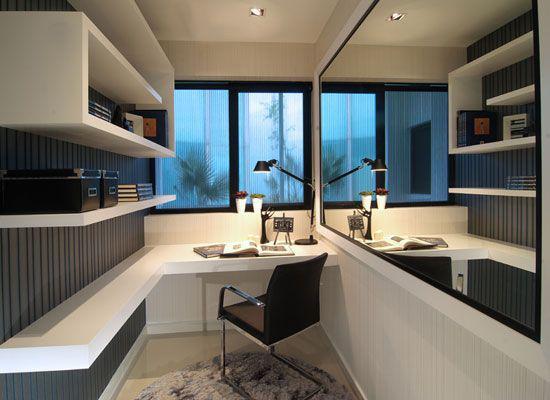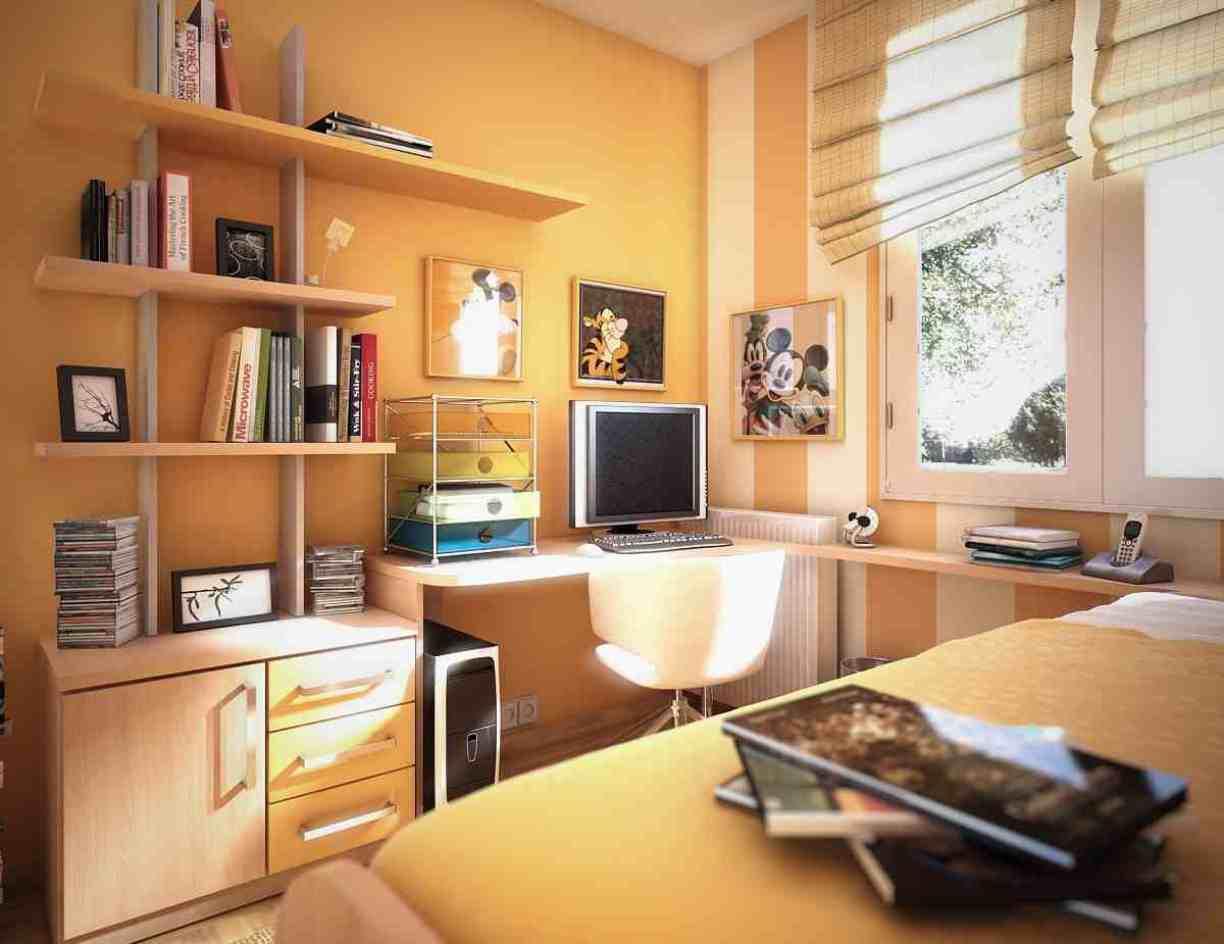The first image is the image on the left, the second image is the image on the right. Assess this claim about the two images: "The left image shows at least one chair in front of a pair of windows with a blue glow, and shelving along one wall.". Correct or not? Answer yes or no. Yes. The first image is the image on the left, the second image is the image on the right. Assess this claim about the two images: "THere are at least three floating bookshelves next to a twin bed.". Correct or not? Answer yes or no. Yes. 